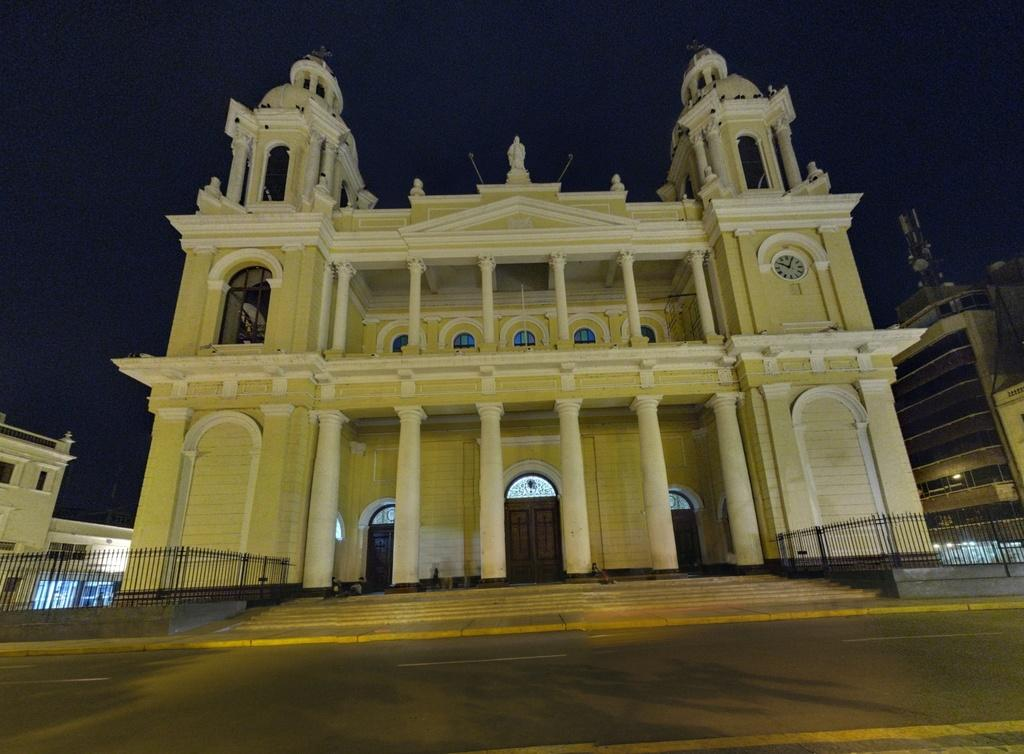What type of structures are present in the image? There is a group of buildings in the image. What material are the railings made of in the image? The railings in the image are made of metal. What architectural feature can be seen in the background of the image? There is a staircase in the background of the image. What is visible in the sky in the image? The sky is visible in the background of the image. What type of scissors can be seen cutting a branch in the image? There are no scissors or branches present in the image. 